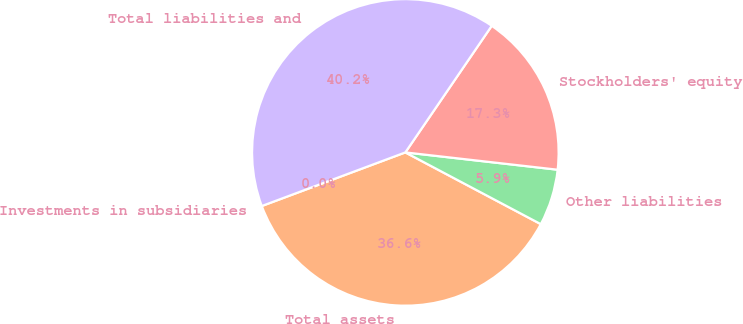Convert chart. <chart><loc_0><loc_0><loc_500><loc_500><pie_chart><fcel>Investments in subsidiaries<fcel>Total assets<fcel>Other liabilities<fcel>Stockholders' equity<fcel>Total liabilities and<nl><fcel>0.0%<fcel>36.56%<fcel>5.95%<fcel>17.27%<fcel>40.22%<nl></chart> 